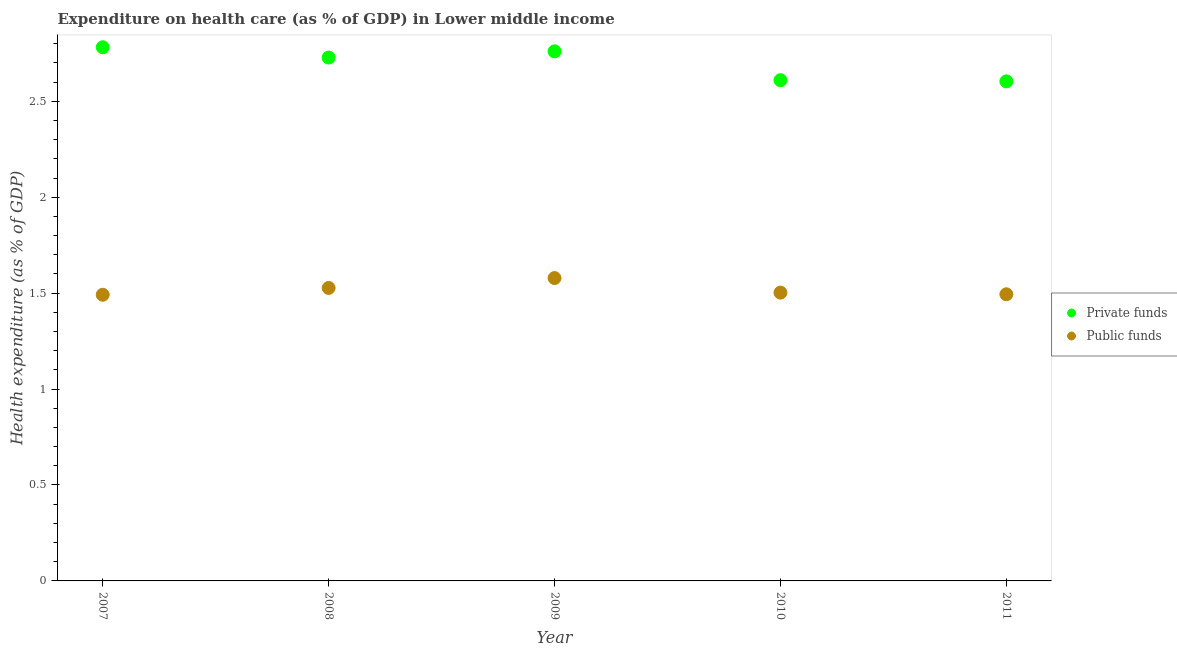How many different coloured dotlines are there?
Offer a terse response. 2. Is the number of dotlines equal to the number of legend labels?
Offer a very short reply. Yes. What is the amount of private funds spent in healthcare in 2008?
Your answer should be very brief. 2.73. Across all years, what is the maximum amount of private funds spent in healthcare?
Your answer should be very brief. 2.78. Across all years, what is the minimum amount of public funds spent in healthcare?
Keep it short and to the point. 1.49. In which year was the amount of private funds spent in healthcare maximum?
Provide a succinct answer. 2007. What is the total amount of private funds spent in healthcare in the graph?
Offer a terse response. 13.48. What is the difference between the amount of private funds spent in healthcare in 2008 and that in 2011?
Your answer should be compact. 0.12. What is the difference between the amount of public funds spent in healthcare in 2011 and the amount of private funds spent in healthcare in 2010?
Ensure brevity in your answer.  -1.12. What is the average amount of private funds spent in healthcare per year?
Offer a very short reply. 2.7. In the year 2010, what is the difference between the amount of public funds spent in healthcare and amount of private funds spent in healthcare?
Offer a terse response. -1.11. In how many years, is the amount of private funds spent in healthcare greater than 0.8 %?
Offer a very short reply. 5. What is the ratio of the amount of private funds spent in healthcare in 2009 to that in 2011?
Give a very brief answer. 1.06. What is the difference between the highest and the second highest amount of public funds spent in healthcare?
Ensure brevity in your answer.  0.05. What is the difference between the highest and the lowest amount of public funds spent in healthcare?
Offer a very short reply. 0.09. Is the sum of the amount of private funds spent in healthcare in 2007 and 2011 greater than the maximum amount of public funds spent in healthcare across all years?
Make the answer very short. Yes. Does the amount of public funds spent in healthcare monotonically increase over the years?
Provide a short and direct response. No. Is the amount of public funds spent in healthcare strictly less than the amount of private funds spent in healthcare over the years?
Your response must be concise. Yes. How many dotlines are there?
Offer a very short reply. 2. What is the difference between two consecutive major ticks on the Y-axis?
Ensure brevity in your answer.  0.5. Does the graph contain any zero values?
Provide a succinct answer. No. Does the graph contain grids?
Ensure brevity in your answer.  No. What is the title of the graph?
Your response must be concise. Expenditure on health care (as % of GDP) in Lower middle income. Does "State government" appear as one of the legend labels in the graph?
Ensure brevity in your answer.  No. What is the label or title of the X-axis?
Give a very brief answer. Year. What is the label or title of the Y-axis?
Give a very brief answer. Health expenditure (as % of GDP). What is the Health expenditure (as % of GDP) in Private funds in 2007?
Ensure brevity in your answer.  2.78. What is the Health expenditure (as % of GDP) of Public funds in 2007?
Your answer should be very brief. 1.49. What is the Health expenditure (as % of GDP) in Private funds in 2008?
Keep it short and to the point. 2.73. What is the Health expenditure (as % of GDP) in Public funds in 2008?
Ensure brevity in your answer.  1.53. What is the Health expenditure (as % of GDP) in Private funds in 2009?
Your answer should be very brief. 2.76. What is the Health expenditure (as % of GDP) of Public funds in 2009?
Your answer should be very brief. 1.58. What is the Health expenditure (as % of GDP) in Private funds in 2010?
Give a very brief answer. 2.61. What is the Health expenditure (as % of GDP) in Public funds in 2010?
Make the answer very short. 1.5. What is the Health expenditure (as % of GDP) in Private funds in 2011?
Ensure brevity in your answer.  2.6. What is the Health expenditure (as % of GDP) in Public funds in 2011?
Ensure brevity in your answer.  1.49. Across all years, what is the maximum Health expenditure (as % of GDP) of Private funds?
Keep it short and to the point. 2.78. Across all years, what is the maximum Health expenditure (as % of GDP) in Public funds?
Provide a succinct answer. 1.58. Across all years, what is the minimum Health expenditure (as % of GDP) of Private funds?
Provide a succinct answer. 2.6. Across all years, what is the minimum Health expenditure (as % of GDP) of Public funds?
Make the answer very short. 1.49. What is the total Health expenditure (as % of GDP) of Private funds in the graph?
Your answer should be compact. 13.48. What is the total Health expenditure (as % of GDP) in Public funds in the graph?
Provide a succinct answer. 7.59. What is the difference between the Health expenditure (as % of GDP) in Private funds in 2007 and that in 2008?
Give a very brief answer. 0.05. What is the difference between the Health expenditure (as % of GDP) in Public funds in 2007 and that in 2008?
Give a very brief answer. -0.04. What is the difference between the Health expenditure (as % of GDP) in Private funds in 2007 and that in 2009?
Offer a very short reply. 0.02. What is the difference between the Health expenditure (as % of GDP) of Public funds in 2007 and that in 2009?
Offer a very short reply. -0.09. What is the difference between the Health expenditure (as % of GDP) of Private funds in 2007 and that in 2010?
Make the answer very short. 0.17. What is the difference between the Health expenditure (as % of GDP) of Public funds in 2007 and that in 2010?
Ensure brevity in your answer.  -0.01. What is the difference between the Health expenditure (as % of GDP) of Private funds in 2007 and that in 2011?
Give a very brief answer. 0.18. What is the difference between the Health expenditure (as % of GDP) of Public funds in 2007 and that in 2011?
Provide a succinct answer. -0. What is the difference between the Health expenditure (as % of GDP) in Private funds in 2008 and that in 2009?
Your answer should be compact. -0.03. What is the difference between the Health expenditure (as % of GDP) of Public funds in 2008 and that in 2009?
Make the answer very short. -0.05. What is the difference between the Health expenditure (as % of GDP) in Private funds in 2008 and that in 2010?
Keep it short and to the point. 0.12. What is the difference between the Health expenditure (as % of GDP) of Public funds in 2008 and that in 2010?
Your answer should be compact. 0.02. What is the difference between the Health expenditure (as % of GDP) in Private funds in 2008 and that in 2011?
Your answer should be compact. 0.12. What is the difference between the Health expenditure (as % of GDP) in Public funds in 2008 and that in 2011?
Provide a succinct answer. 0.03. What is the difference between the Health expenditure (as % of GDP) of Private funds in 2009 and that in 2010?
Ensure brevity in your answer.  0.15. What is the difference between the Health expenditure (as % of GDP) in Public funds in 2009 and that in 2010?
Make the answer very short. 0.08. What is the difference between the Health expenditure (as % of GDP) in Private funds in 2009 and that in 2011?
Offer a terse response. 0.16. What is the difference between the Health expenditure (as % of GDP) of Public funds in 2009 and that in 2011?
Your answer should be very brief. 0.08. What is the difference between the Health expenditure (as % of GDP) in Private funds in 2010 and that in 2011?
Make the answer very short. 0.01. What is the difference between the Health expenditure (as % of GDP) in Public funds in 2010 and that in 2011?
Make the answer very short. 0.01. What is the difference between the Health expenditure (as % of GDP) in Private funds in 2007 and the Health expenditure (as % of GDP) in Public funds in 2008?
Provide a succinct answer. 1.25. What is the difference between the Health expenditure (as % of GDP) of Private funds in 2007 and the Health expenditure (as % of GDP) of Public funds in 2009?
Make the answer very short. 1.2. What is the difference between the Health expenditure (as % of GDP) in Private funds in 2007 and the Health expenditure (as % of GDP) in Public funds in 2010?
Keep it short and to the point. 1.28. What is the difference between the Health expenditure (as % of GDP) in Private funds in 2007 and the Health expenditure (as % of GDP) in Public funds in 2011?
Your answer should be compact. 1.29. What is the difference between the Health expenditure (as % of GDP) of Private funds in 2008 and the Health expenditure (as % of GDP) of Public funds in 2009?
Give a very brief answer. 1.15. What is the difference between the Health expenditure (as % of GDP) in Private funds in 2008 and the Health expenditure (as % of GDP) in Public funds in 2010?
Offer a terse response. 1.23. What is the difference between the Health expenditure (as % of GDP) of Private funds in 2008 and the Health expenditure (as % of GDP) of Public funds in 2011?
Provide a succinct answer. 1.23. What is the difference between the Health expenditure (as % of GDP) of Private funds in 2009 and the Health expenditure (as % of GDP) of Public funds in 2010?
Keep it short and to the point. 1.26. What is the difference between the Health expenditure (as % of GDP) in Private funds in 2009 and the Health expenditure (as % of GDP) in Public funds in 2011?
Give a very brief answer. 1.27. What is the difference between the Health expenditure (as % of GDP) in Private funds in 2010 and the Health expenditure (as % of GDP) in Public funds in 2011?
Give a very brief answer. 1.12. What is the average Health expenditure (as % of GDP) of Private funds per year?
Provide a succinct answer. 2.7. What is the average Health expenditure (as % of GDP) of Public funds per year?
Your answer should be compact. 1.52. In the year 2007, what is the difference between the Health expenditure (as % of GDP) of Private funds and Health expenditure (as % of GDP) of Public funds?
Your answer should be very brief. 1.29. In the year 2008, what is the difference between the Health expenditure (as % of GDP) in Private funds and Health expenditure (as % of GDP) in Public funds?
Ensure brevity in your answer.  1.2. In the year 2009, what is the difference between the Health expenditure (as % of GDP) in Private funds and Health expenditure (as % of GDP) in Public funds?
Make the answer very short. 1.18. In the year 2010, what is the difference between the Health expenditure (as % of GDP) of Private funds and Health expenditure (as % of GDP) of Public funds?
Offer a very short reply. 1.11. In the year 2011, what is the difference between the Health expenditure (as % of GDP) of Private funds and Health expenditure (as % of GDP) of Public funds?
Your answer should be very brief. 1.11. What is the ratio of the Health expenditure (as % of GDP) of Private funds in 2007 to that in 2008?
Your answer should be very brief. 1.02. What is the ratio of the Health expenditure (as % of GDP) of Public funds in 2007 to that in 2008?
Ensure brevity in your answer.  0.98. What is the ratio of the Health expenditure (as % of GDP) of Private funds in 2007 to that in 2009?
Offer a terse response. 1.01. What is the ratio of the Health expenditure (as % of GDP) of Public funds in 2007 to that in 2009?
Offer a terse response. 0.94. What is the ratio of the Health expenditure (as % of GDP) of Private funds in 2007 to that in 2010?
Your answer should be very brief. 1.07. What is the ratio of the Health expenditure (as % of GDP) in Private funds in 2007 to that in 2011?
Give a very brief answer. 1.07. What is the ratio of the Health expenditure (as % of GDP) in Public funds in 2007 to that in 2011?
Make the answer very short. 1. What is the ratio of the Health expenditure (as % of GDP) of Private funds in 2008 to that in 2009?
Keep it short and to the point. 0.99. What is the ratio of the Health expenditure (as % of GDP) of Public funds in 2008 to that in 2009?
Offer a terse response. 0.97. What is the ratio of the Health expenditure (as % of GDP) of Private funds in 2008 to that in 2010?
Make the answer very short. 1.05. What is the ratio of the Health expenditure (as % of GDP) of Public funds in 2008 to that in 2010?
Offer a very short reply. 1.02. What is the ratio of the Health expenditure (as % of GDP) of Private funds in 2008 to that in 2011?
Offer a very short reply. 1.05. What is the ratio of the Health expenditure (as % of GDP) in Public funds in 2008 to that in 2011?
Make the answer very short. 1.02. What is the ratio of the Health expenditure (as % of GDP) of Private funds in 2009 to that in 2010?
Ensure brevity in your answer.  1.06. What is the ratio of the Health expenditure (as % of GDP) in Public funds in 2009 to that in 2010?
Your answer should be compact. 1.05. What is the ratio of the Health expenditure (as % of GDP) in Private funds in 2009 to that in 2011?
Ensure brevity in your answer.  1.06. What is the ratio of the Health expenditure (as % of GDP) in Public funds in 2009 to that in 2011?
Provide a succinct answer. 1.06. What is the ratio of the Health expenditure (as % of GDP) in Public funds in 2010 to that in 2011?
Your answer should be compact. 1.01. What is the difference between the highest and the second highest Health expenditure (as % of GDP) of Private funds?
Keep it short and to the point. 0.02. What is the difference between the highest and the second highest Health expenditure (as % of GDP) in Public funds?
Offer a very short reply. 0.05. What is the difference between the highest and the lowest Health expenditure (as % of GDP) of Private funds?
Keep it short and to the point. 0.18. What is the difference between the highest and the lowest Health expenditure (as % of GDP) of Public funds?
Your response must be concise. 0.09. 